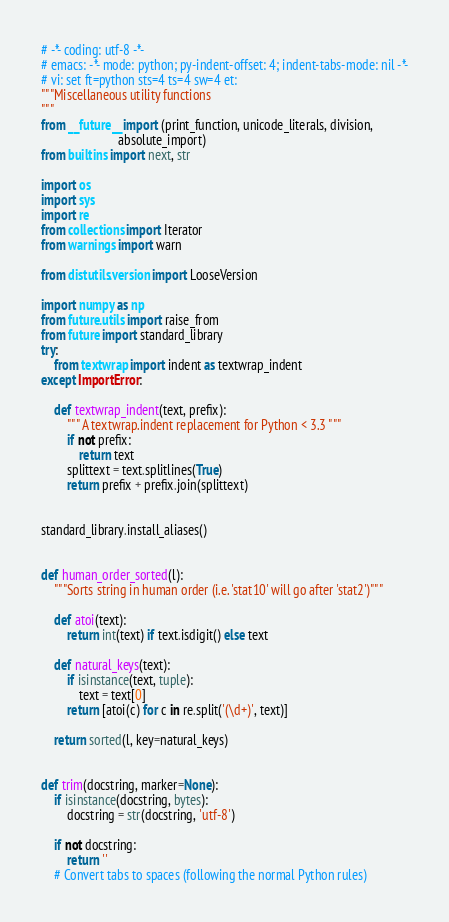<code> <loc_0><loc_0><loc_500><loc_500><_Python_># -*- coding: utf-8 -*-
# emacs: -*- mode: python; py-indent-offset: 4; indent-tabs-mode: nil -*-
# vi: set ft=python sts=4 ts=4 sw=4 et:
"""Miscellaneous utility functions
"""
from __future__ import (print_function, unicode_literals, division,
                        absolute_import)
from builtins import next, str

import os
import sys
import re
from collections import Iterator
from warnings import warn

from distutils.version import LooseVersion

import numpy as np
from future.utils import raise_from
from future import standard_library
try:
    from textwrap import indent as textwrap_indent
except ImportError:

    def textwrap_indent(text, prefix):
        """ A textwrap.indent replacement for Python < 3.3 """
        if not prefix:
            return text
        splittext = text.splitlines(True)
        return prefix + prefix.join(splittext)


standard_library.install_aliases()


def human_order_sorted(l):
    """Sorts string in human order (i.e. 'stat10' will go after 'stat2')"""

    def atoi(text):
        return int(text) if text.isdigit() else text

    def natural_keys(text):
        if isinstance(text, tuple):
            text = text[0]
        return [atoi(c) for c in re.split('(\d+)', text)]

    return sorted(l, key=natural_keys)


def trim(docstring, marker=None):
    if isinstance(docstring, bytes):
        docstring = str(docstring, 'utf-8')

    if not docstring:
        return ''
    # Convert tabs to spaces (following the normal Python rules)</code> 